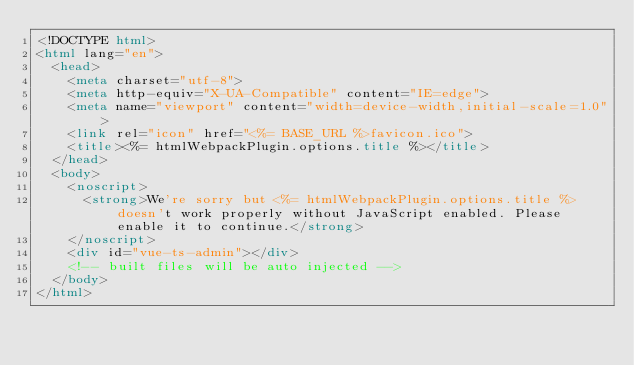Convert code to text. <code><loc_0><loc_0><loc_500><loc_500><_HTML_><!DOCTYPE html>
<html lang="en">
  <head>
    <meta charset="utf-8">
    <meta http-equiv="X-UA-Compatible" content="IE=edge">
    <meta name="viewport" content="width=device-width,initial-scale=1.0">
    <link rel="icon" href="<%= BASE_URL %>favicon.ico">
    <title><%= htmlWebpackPlugin.options.title %></title>
  </head>
  <body>
    <noscript>
      <strong>We're sorry but <%= htmlWebpackPlugin.options.title %> doesn't work properly without JavaScript enabled. Please enable it to continue.</strong>
    </noscript>
    <div id="vue-ts-admin"></div>
    <!-- built files will be auto injected -->
  </body>
</html>
</code> 